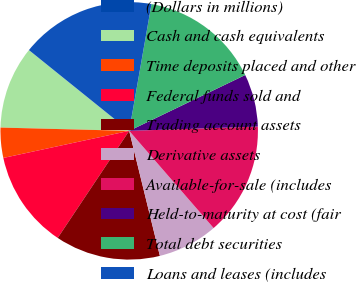Convert chart. <chart><loc_0><loc_0><loc_500><loc_500><pie_chart><fcel>(Dollars in millions)<fcel>Cash and cash equivalents<fcel>Time deposits placed and other<fcel>Federal funds sold and<fcel>Trading account assets<fcel>Derivative assets<fcel>Available-for-sale (includes<fcel>Held-to-maturity at cost (fair<fcel>Total debt securities<fcel>Loans and leases (includes<nl><fcel>0.01%<fcel>10.38%<fcel>3.78%<fcel>12.26%<fcel>13.2%<fcel>7.55%<fcel>14.15%<fcel>6.61%<fcel>15.09%<fcel>16.98%<nl></chart> 